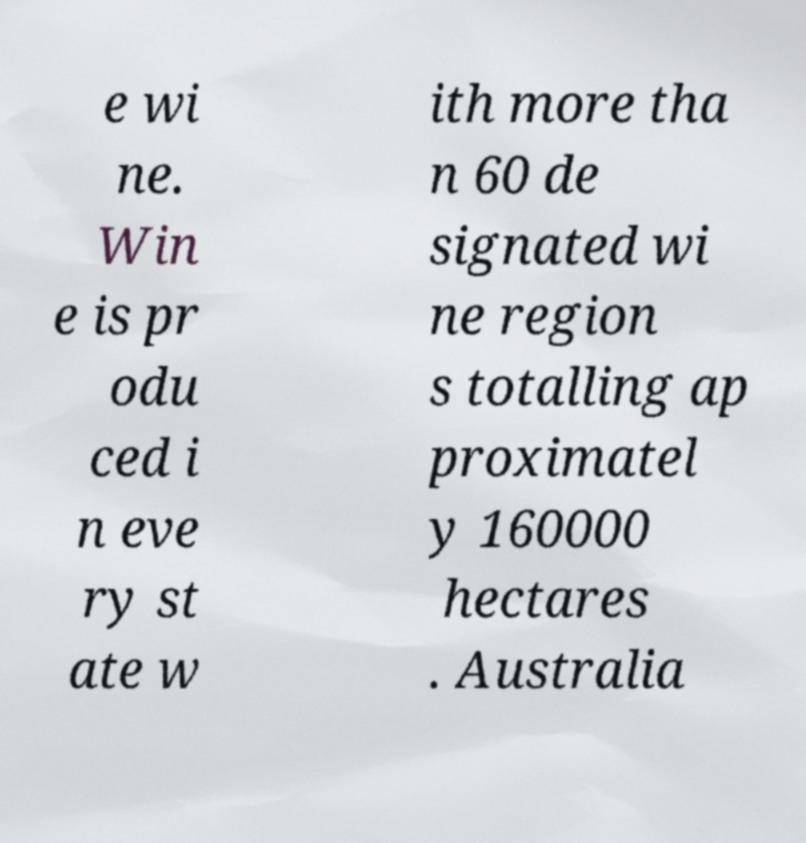Please read and relay the text visible in this image. What does it say? e wi ne. Win e is pr odu ced i n eve ry st ate w ith more tha n 60 de signated wi ne region s totalling ap proximatel y 160000 hectares . Australia 